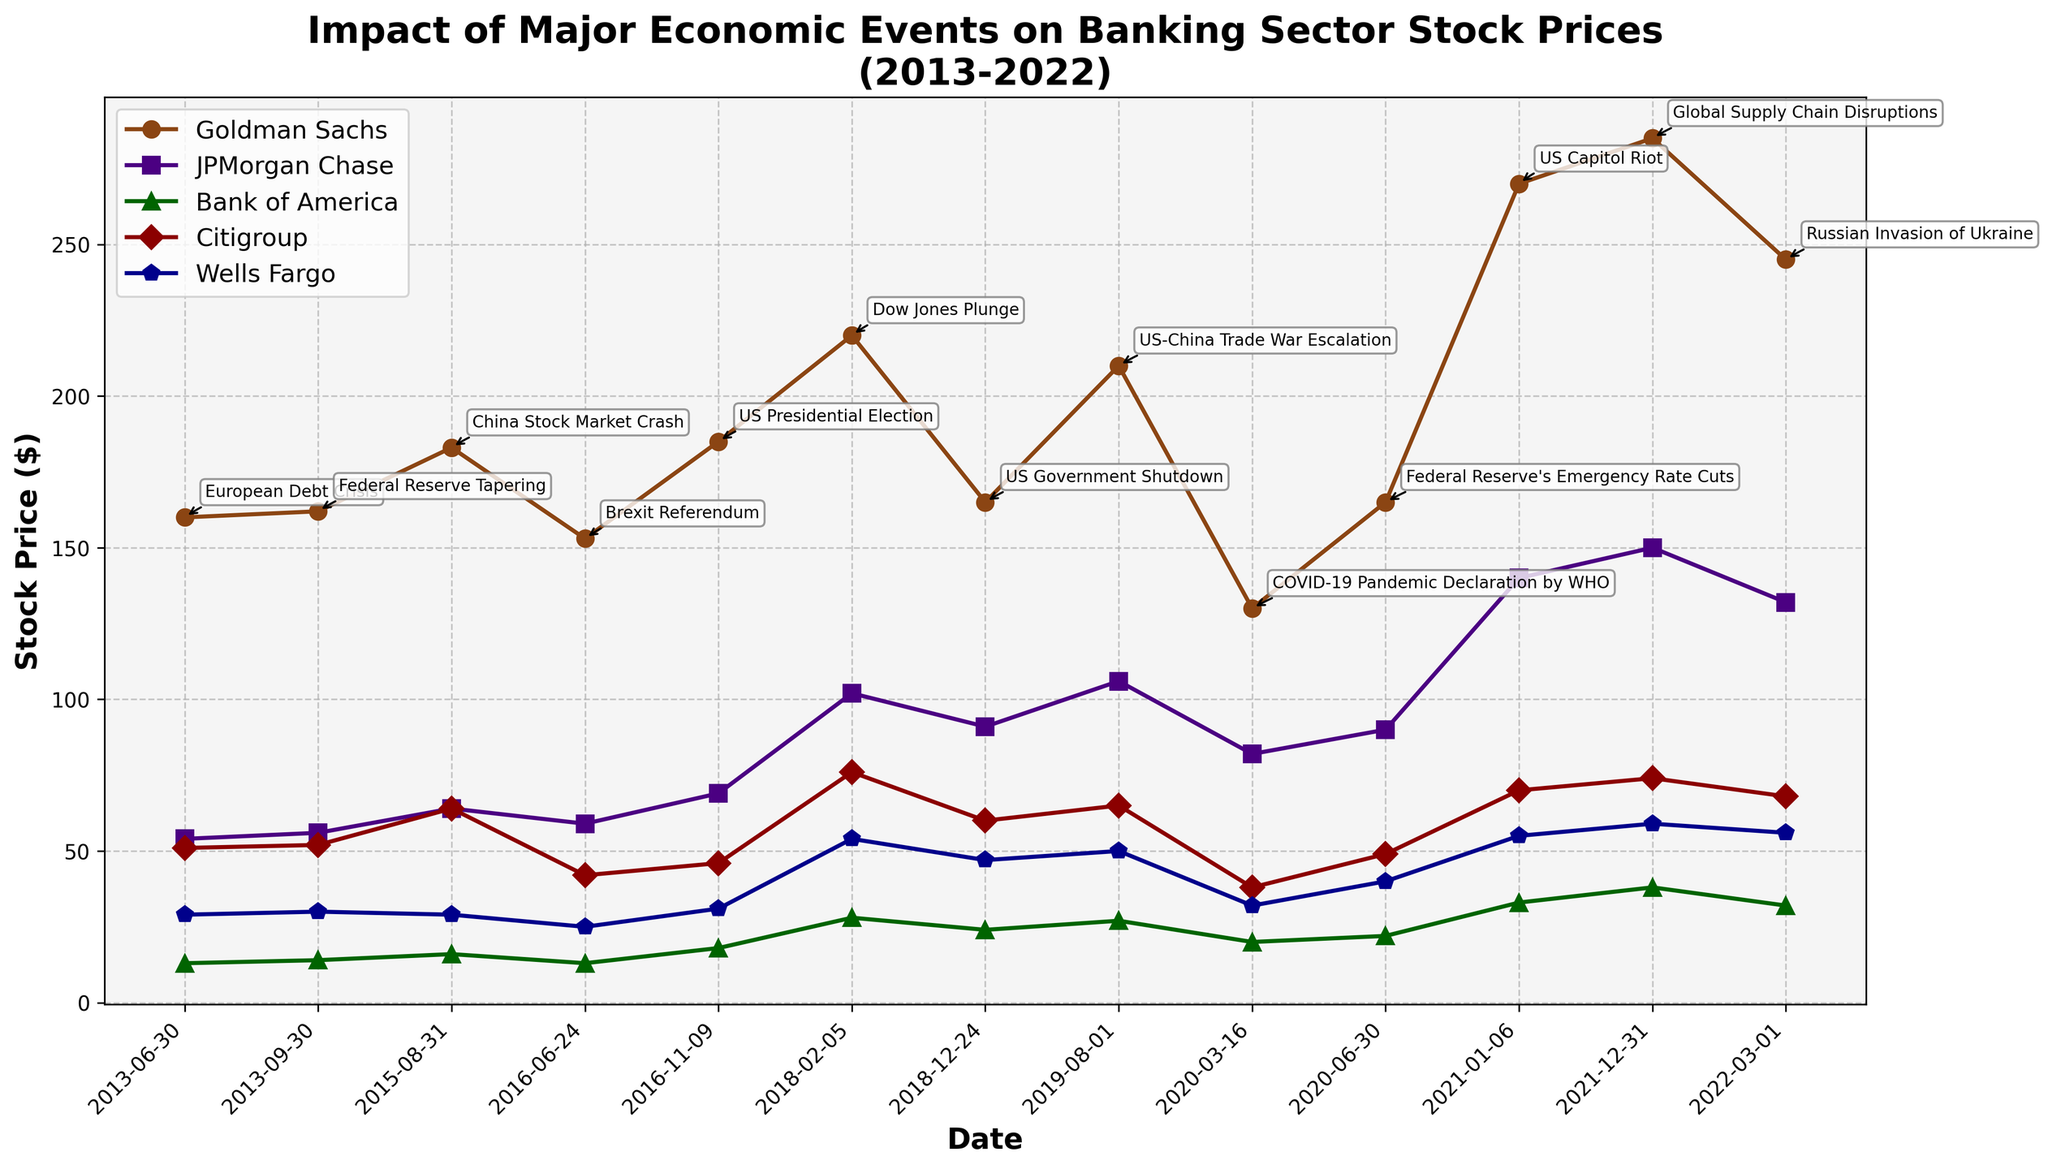What is the title of the plot? The title is located at the top of the plot and is usually the largest text. The title reads: "Impact of Major Economic Events on Banking Sector Stock Prices (2013-2022)"
Answer: Impact of Major Economic Events on Banking Sector Stock Prices (2013-2022) How many banks are represented in the plot? By counting the number of different lines in the plot and checking the legend, we see that there are 5 banks represented: Goldman Sachs, JPMorgan Chase, Bank of America, Citigroup, and Wells Fargo
Answer: 5 Which bank had the highest stock price at the end of the period in March 2022? By looking at the endpoint in March 2022 on the x-axis and finding which line is highest, we can see that JPMorgan Chase had the highest stock price with $150.
Answer: JPMorgan Chase What was the stock price of Citigroup during the Brexit Referendum event? Locate the point on the Citigroup line corresponding to the Brexit Referendum event in 2016. The stock price is approximately $42.
Answer: $42 How did the stock price of Wells Fargo change from the US Presidential Election in 2016 to the Global Supply Chain Disruptions in 2021? Locate the Wells Fargo stock price at the dates of US Presidential Election (2016) and Global Supply Chain Disruptions (2021). The price increased from $31 to $59.
Answer: Increased from $31 to $59 Which economic event caused the largest drop in Goldman Sachs stock prices and by how much? Compare the stock prices of Goldman Sachs at each event. The largest drop is from the US Capitol Riot in January 2021 to the Russian Invasion of Ukraine in March 2022, where the price dropped from $270 to $245, a difference of $25.
Answer: US Capitol Riot ($25) What's the difference in the stock price of Bank of America between the COVID-19 Pandemic Declaration by WHO and the Federal Reserve's Emergency Rate Cuts? Find the stock prices of Bank of America at these two events and calculate the difference: $22 (Emergency Rate Cuts) - $20 (Pandemic Declaration) = $2.
Answer: $2 How many major economic events are annotated in the plot? Count the annotated events in the plot, which are placed at the corresponding dates on the x-axis. There are 12 events annotated.
Answer: 12 Which two consecutive events saw an increase in the Wells Fargo stock price? Look at the changes in Wells Fargo's stock price for each pair of consecutive events; between US Government Shutdown and US-China Trade War Escalation (increase from $47 to $50), and between Federal Reserve's Emergency Rate Cuts and US Capitol Riot (increase from $40 to $55).
Answer: US Government Shutdown and US-China Trade War Escalation, Federal Reserve's Emergency Rate Cuts and US Capitol Riot 